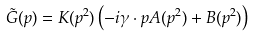<formula> <loc_0><loc_0><loc_500><loc_500>\tilde { G } ( p ) = K ( p ^ { 2 } ) \left ( - i \gamma \cdot p A ( p ^ { 2 } ) + B ( p ^ { 2 } ) \right )</formula> 